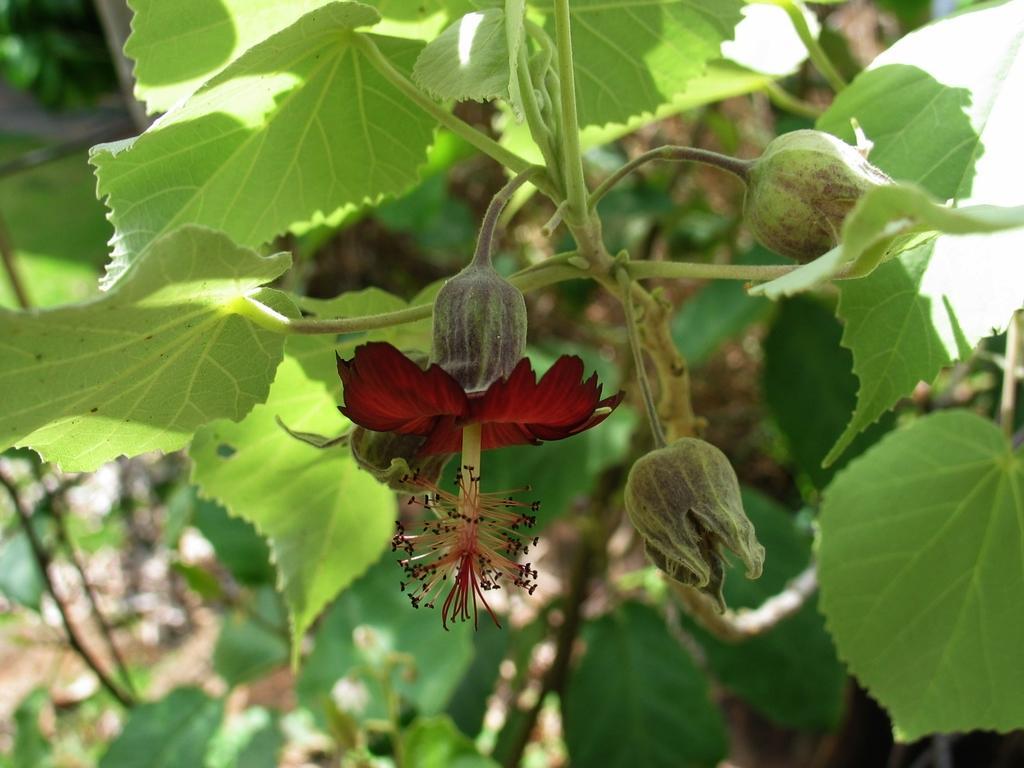How would you summarize this image in a sentence or two? In this picture I can see a flower in the middle, there are buds and plants in this image. 